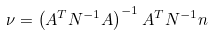<formula> <loc_0><loc_0><loc_500><loc_500>\nu = \left ( A ^ { T } N ^ { - 1 } A \right ) ^ { - 1 } A ^ { T } N ^ { - 1 } n</formula> 